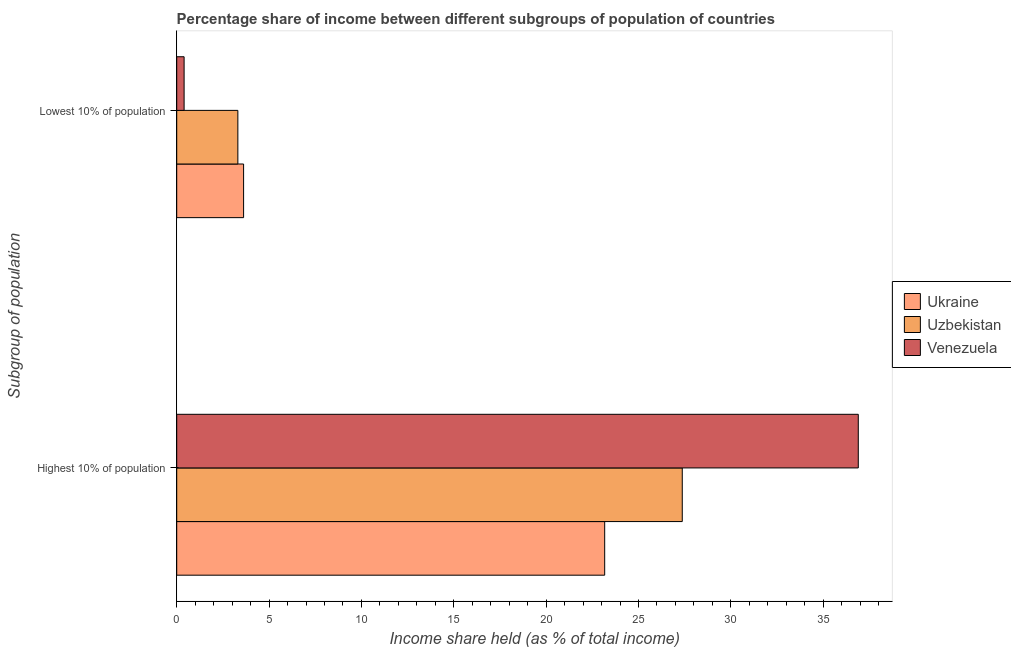Are the number of bars on each tick of the Y-axis equal?
Ensure brevity in your answer.  Yes. How many bars are there on the 2nd tick from the top?
Your answer should be very brief. 3. How many bars are there on the 1st tick from the bottom?
Provide a succinct answer. 3. What is the label of the 1st group of bars from the top?
Your answer should be very brief. Lowest 10% of population. What is the income share held by lowest 10% of the population in Uzbekistan?
Your response must be concise. 3.31. Across all countries, what is the maximum income share held by highest 10% of the population?
Make the answer very short. 36.9. In which country was the income share held by lowest 10% of the population maximum?
Give a very brief answer. Ukraine. In which country was the income share held by lowest 10% of the population minimum?
Provide a short and direct response. Venezuela. What is the total income share held by highest 10% of the population in the graph?
Keep it short and to the point. 87.44. What is the difference between the income share held by highest 10% of the population in Ukraine and that in Venezuela?
Offer a very short reply. -13.73. What is the difference between the income share held by lowest 10% of the population in Ukraine and the income share held by highest 10% of the population in Uzbekistan?
Your answer should be very brief. -23.75. What is the average income share held by highest 10% of the population per country?
Your response must be concise. 29.15. What is the difference between the income share held by highest 10% of the population and income share held by lowest 10% of the population in Ukraine?
Make the answer very short. 19.55. What is the ratio of the income share held by highest 10% of the population in Uzbekistan to that in Ukraine?
Your response must be concise. 1.18. Is the income share held by highest 10% of the population in Uzbekistan less than that in Venezuela?
Give a very brief answer. Yes. What does the 3rd bar from the top in Highest 10% of population represents?
Offer a terse response. Ukraine. What does the 3rd bar from the bottom in Lowest 10% of population represents?
Make the answer very short. Venezuela. How many countries are there in the graph?
Your answer should be very brief. 3. What is the difference between two consecutive major ticks on the X-axis?
Your answer should be compact. 5. Are the values on the major ticks of X-axis written in scientific E-notation?
Your response must be concise. No. Does the graph contain any zero values?
Ensure brevity in your answer.  No. Where does the legend appear in the graph?
Ensure brevity in your answer.  Center right. What is the title of the graph?
Your answer should be compact. Percentage share of income between different subgroups of population of countries. Does "Guatemala" appear as one of the legend labels in the graph?
Ensure brevity in your answer.  No. What is the label or title of the X-axis?
Give a very brief answer. Income share held (as % of total income). What is the label or title of the Y-axis?
Your answer should be compact. Subgroup of population. What is the Income share held (as % of total income) of Ukraine in Highest 10% of population?
Your answer should be compact. 23.17. What is the Income share held (as % of total income) in Uzbekistan in Highest 10% of population?
Offer a very short reply. 27.37. What is the Income share held (as % of total income) of Venezuela in Highest 10% of population?
Ensure brevity in your answer.  36.9. What is the Income share held (as % of total income) of Ukraine in Lowest 10% of population?
Keep it short and to the point. 3.62. What is the Income share held (as % of total income) of Uzbekistan in Lowest 10% of population?
Keep it short and to the point. 3.31. Across all Subgroup of population, what is the maximum Income share held (as % of total income) of Ukraine?
Your response must be concise. 23.17. Across all Subgroup of population, what is the maximum Income share held (as % of total income) in Uzbekistan?
Give a very brief answer. 27.37. Across all Subgroup of population, what is the maximum Income share held (as % of total income) of Venezuela?
Make the answer very short. 36.9. Across all Subgroup of population, what is the minimum Income share held (as % of total income) in Ukraine?
Your response must be concise. 3.62. Across all Subgroup of population, what is the minimum Income share held (as % of total income) of Uzbekistan?
Your response must be concise. 3.31. What is the total Income share held (as % of total income) in Ukraine in the graph?
Offer a terse response. 26.79. What is the total Income share held (as % of total income) of Uzbekistan in the graph?
Offer a very short reply. 30.68. What is the total Income share held (as % of total income) of Venezuela in the graph?
Your answer should be compact. 37.3. What is the difference between the Income share held (as % of total income) of Ukraine in Highest 10% of population and that in Lowest 10% of population?
Your answer should be compact. 19.55. What is the difference between the Income share held (as % of total income) of Uzbekistan in Highest 10% of population and that in Lowest 10% of population?
Offer a very short reply. 24.06. What is the difference between the Income share held (as % of total income) of Venezuela in Highest 10% of population and that in Lowest 10% of population?
Make the answer very short. 36.5. What is the difference between the Income share held (as % of total income) in Ukraine in Highest 10% of population and the Income share held (as % of total income) in Uzbekistan in Lowest 10% of population?
Your answer should be compact. 19.86. What is the difference between the Income share held (as % of total income) in Ukraine in Highest 10% of population and the Income share held (as % of total income) in Venezuela in Lowest 10% of population?
Keep it short and to the point. 22.77. What is the difference between the Income share held (as % of total income) in Uzbekistan in Highest 10% of population and the Income share held (as % of total income) in Venezuela in Lowest 10% of population?
Provide a succinct answer. 26.97. What is the average Income share held (as % of total income) in Ukraine per Subgroup of population?
Your answer should be very brief. 13.39. What is the average Income share held (as % of total income) of Uzbekistan per Subgroup of population?
Provide a short and direct response. 15.34. What is the average Income share held (as % of total income) in Venezuela per Subgroup of population?
Ensure brevity in your answer.  18.65. What is the difference between the Income share held (as % of total income) of Ukraine and Income share held (as % of total income) of Uzbekistan in Highest 10% of population?
Provide a short and direct response. -4.2. What is the difference between the Income share held (as % of total income) in Ukraine and Income share held (as % of total income) in Venezuela in Highest 10% of population?
Give a very brief answer. -13.73. What is the difference between the Income share held (as % of total income) of Uzbekistan and Income share held (as % of total income) of Venezuela in Highest 10% of population?
Your response must be concise. -9.53. What is the difference between the Income share held (as % of total income) in Ukraine and Income share held (as % of total income) in Uzbekistan in Lowest 10% of population?
Make the answer very short. 0.31. What is the difference between the Income share held (as % of total income) in Ukraine and Income share held (as % of total income) in Venezuela in Lowest 10% of population?
Offer a very short reply. 3.22. What is the difference between the Income share held (as % of total income) in Uzbekistan and Income share held (as % of total income) in Venezuela in Lowest 10% of population?
Offer a very short reply. 2.91. What is the ratio of the Income share held (as % of total income) in Ukraine in Highest 10% of population to that in Lowest 10% of population?
Offer a terse response. 6.4. What is the ratio of the Income share held (as % of total income) of Uzbekistan in Highest 10% of population to that in Lowest 10% of population?
Your answer should be compact. 8.27. What is the ratio of the Income share held (as % of total income) in Venezuela in Highest 10% of population to that in Lowest 10% of population?
Provide a short and direct response. 92.25. What is the difference between the highest and the second highest Income share held (as % of total income) of Ukraine?
Your response must be concise. 19.55. What is the difference between the highest and the second highest Income share held (as % of total income) in Uzbekistan?
Ensure brevity in your answer.  24.06. What is the difference between the highest and the second highest Income share held (as % of total income) in Venezuela?
Offer a terse response. 36.5. What is the difference between the highest and the lowest Income share held (as % of total income) of Ukraine?
Give a very brief answer. 19.55. What is the difference between the highest and the lowest Income share held (as % of total income) in Uzbekistan?
Your response must be concise. 24.06. What is the difference between the highest and the lowest Income share held (as % of total income) of Venezuela?
Provide a succinct answer. 36.5. 